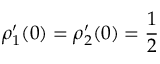Convert formula to latex. <formula><loc_0><loc_0><loc_500><loc_500>\rho _ { 1 } ^ { \prime } ( 0 ) = \rho _ { 2 } ^ { \prime } ( 0 ) = \frac { 1 } { 2 }</formula> 